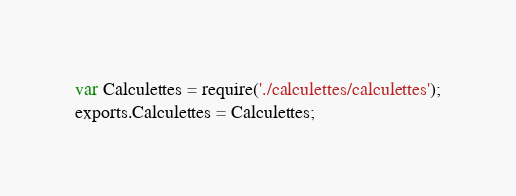Convert code to text. <code><loc_0><loc_0><loc_500><loc_500><_JavaScript_>var Calculettes = require('./calculettes/calculettes');
exports.Calculettes = Calculettes;
</code> 